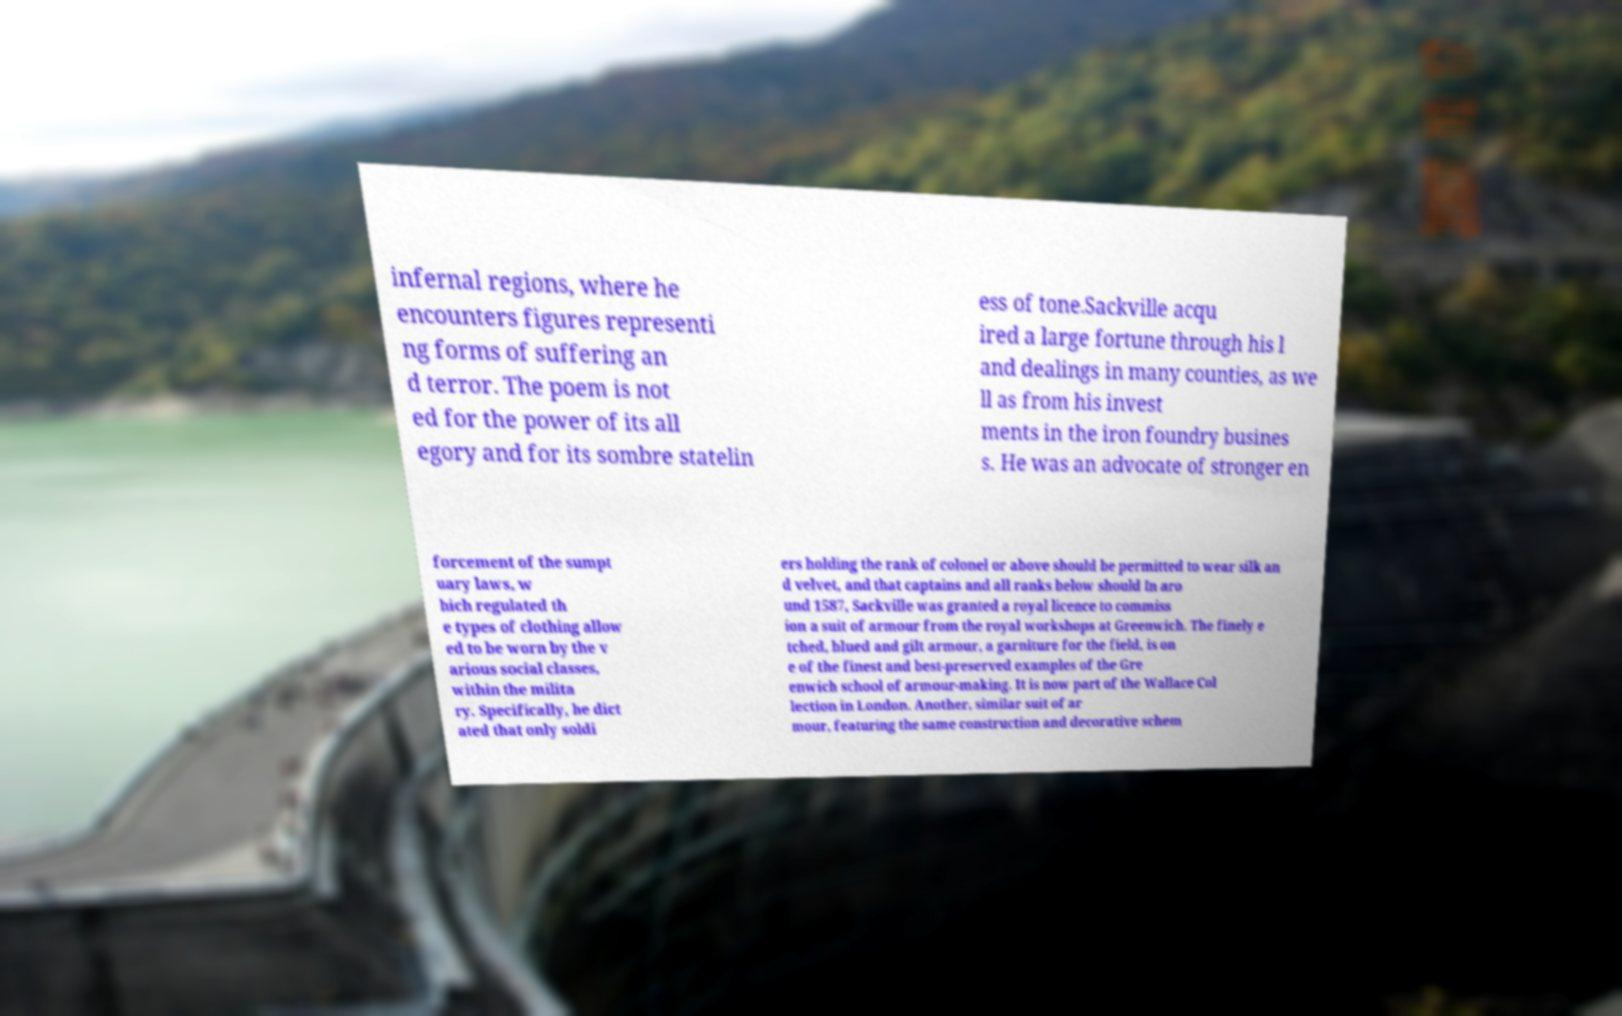For documentation purposes, I need the text within this image transcribed. Could you provide that? infernal regions, where he encounters figures representi ng forms of suffering an d terror. The poem is not ed for the power of its all egory and for its sombre statelin ess of tone.Sackville acqu ired a large fortune through his l and dealings in many counties, as we ll as from his invest ments in the iron foundry busines s. He was an advocate of stronger en forcement of the sumpt uary laws, w hich regulated th e types of clothing allow ed to be worn by the v arious social classes, within the milita ry. Specifically, he dict ated that only soldi ers holding the rank of colonel or above should be permitted to wear silk an d velvet, and that captains and all ranks below should In aro und 1587, Sackville was granted a royal licence to commiss ion a suit of armour from the royal workshops at Greenwich. The finely e tched, blued and gilt armour, a garniture for the field, is on e of the finest and best-preserved examples of the Gre enwich school of armour-making. It is now part of the Wallace Col lection in London. Another, similar suit of ar mour, featuring the same construction and decorative schem 